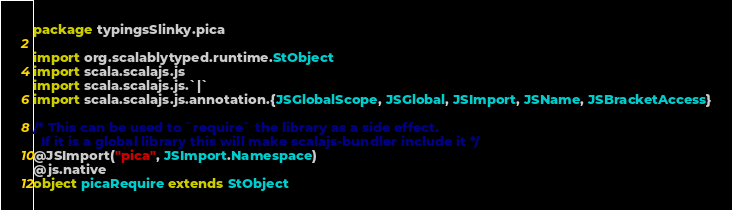Convert code to text. <code><loc_0><loc_0><loc_500><loc_500><_Scala_>package typingsSlinky.pica

import org.scalablytyped.runtime.StObject
import scala.scalajs.js
import scala.scalajs.js.`|`
import scala.scalajs.js.annotation.{JSGlobalScope, JSGlobal, JSImport, JSName, JSBracketAccess}

/* This can be used to `require` the library as a side effect.
  If it is a global library this will make scalajs-bundler include it */
@JSImport("pica", JSImport.Namespace)
@js.native
object picaRequire extends StObject
</code> 